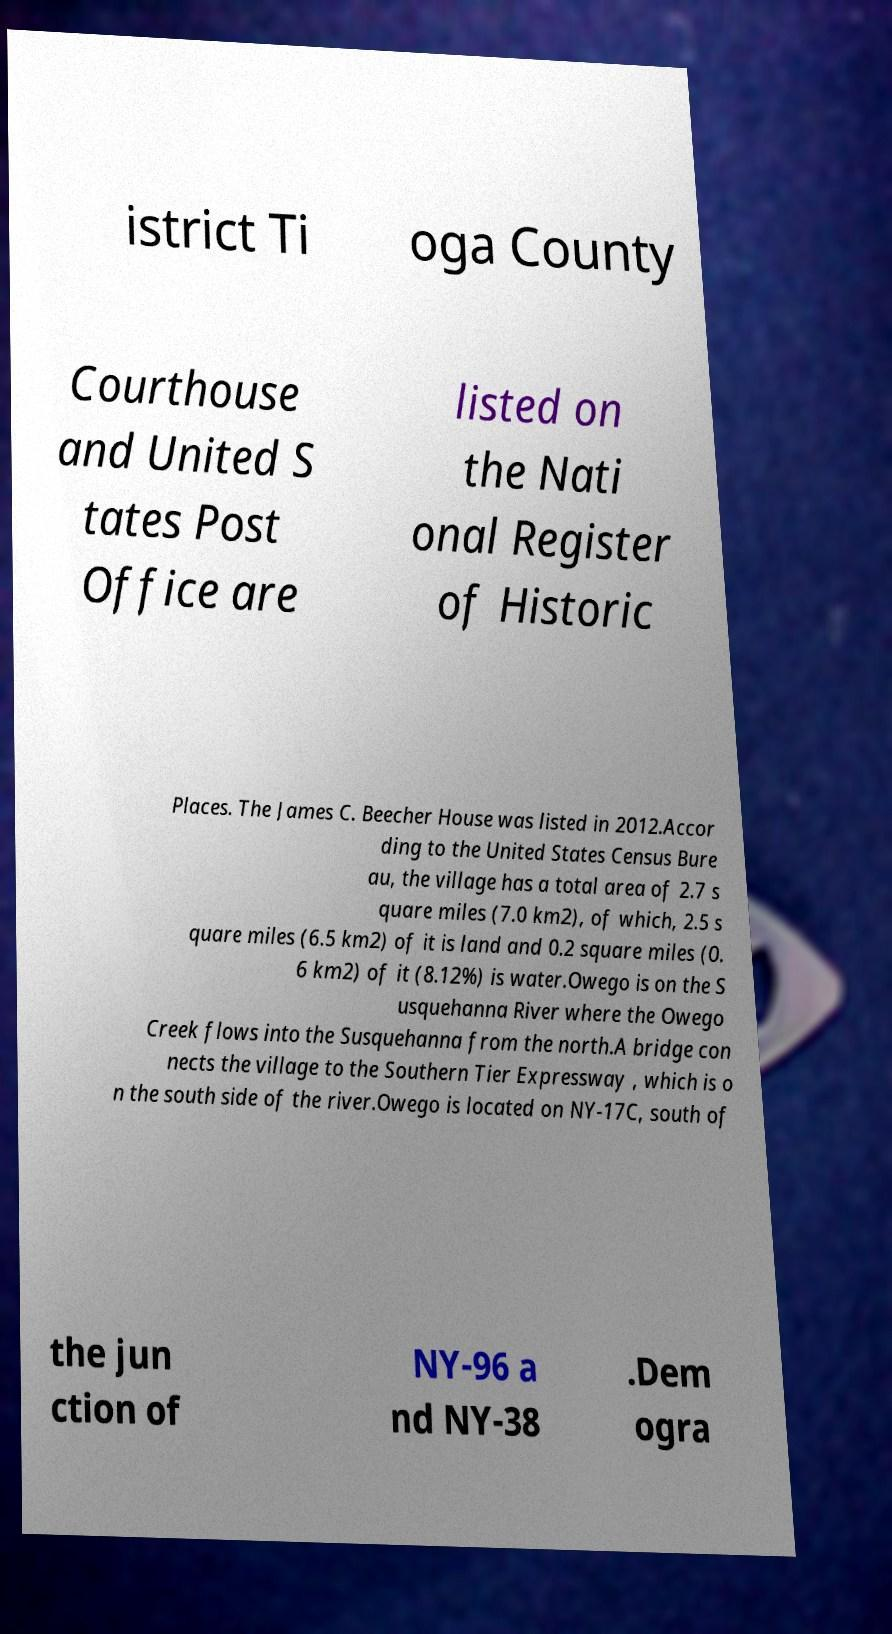I need the written content from this picture converted into text. Can you do that? istrict Ti oga County Courthouse and United S tates Post Office are listed on the Nati onal Register of Historic Places. The James C. Beecher House was listed in 2012.Accor ding to the United States Census Bure au, the village has a total area of 2.7 s quare miles (7.0 km2), of which, 2.5 s quare miles (6.5 km2) of it is land and 0.2 square miles (0. 6 km2) of it (8.12%) is water.Owego is on the S usquehanna River where the Owego Creek flows into the Susquehanna from the north.A bridge con nects the village to the Southern Tier Expressway , which is o n the south side of the river.Owego is located on NY-17C, south of the jun ction of NY-96 a nd NY-38 .Dem ogra 